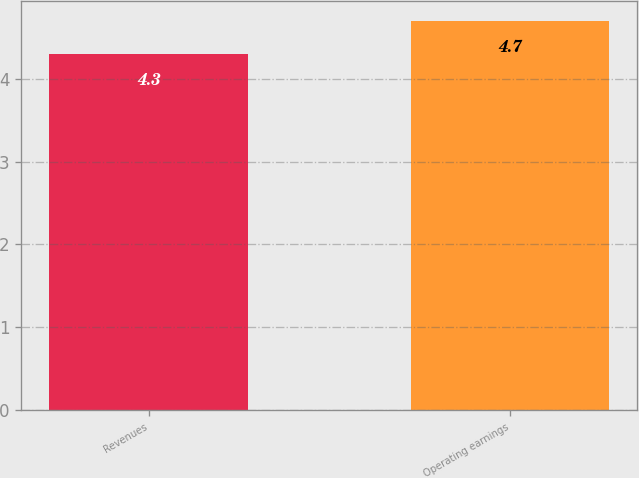Convert chart to OTSL. <chart><loc_0><loc_0><loc_500><loc_500><bar_chart><fcel>Revenues<fcel>Operating earnings<nl><fcel>4.3<fcel>4.7<nl></chart> 